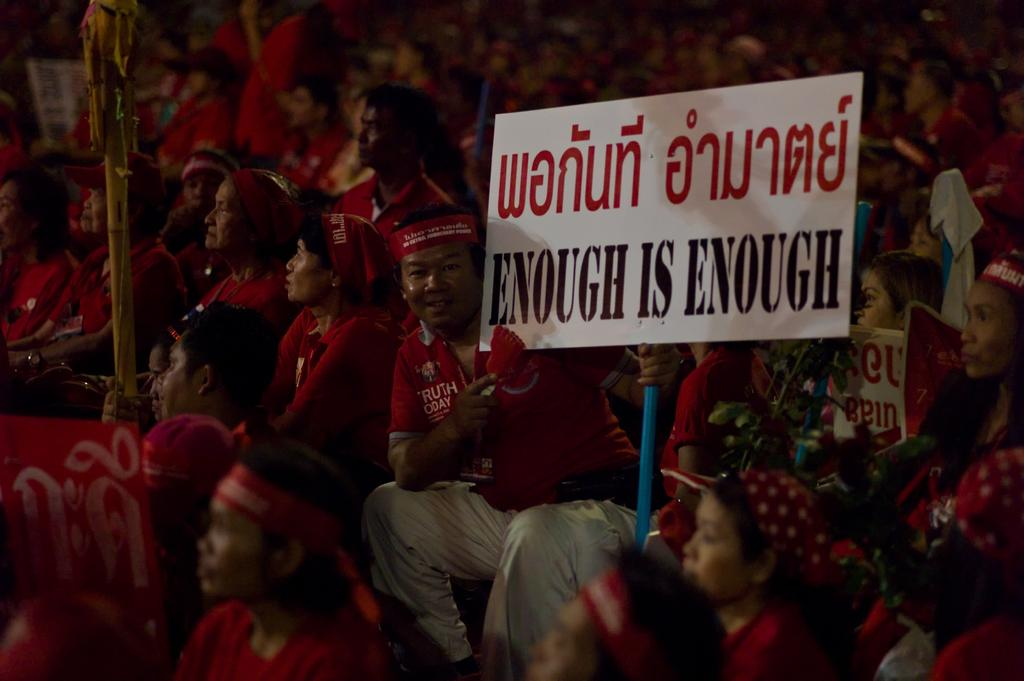What is the main subject of the image? The main subject of the image is a crowd. What are the majority of people in the crowd wearing? Most people in the crowd are wearing red dresses. What are some people in the crowd holding? Some people in the crowd are holding boards in their hands. Can you see any nests in the image? There are no nests visible in the image. Are the people in the crowd swimming in the image? There is no indication of swimming in the image; it features a crowd of people standing or holding boards. 